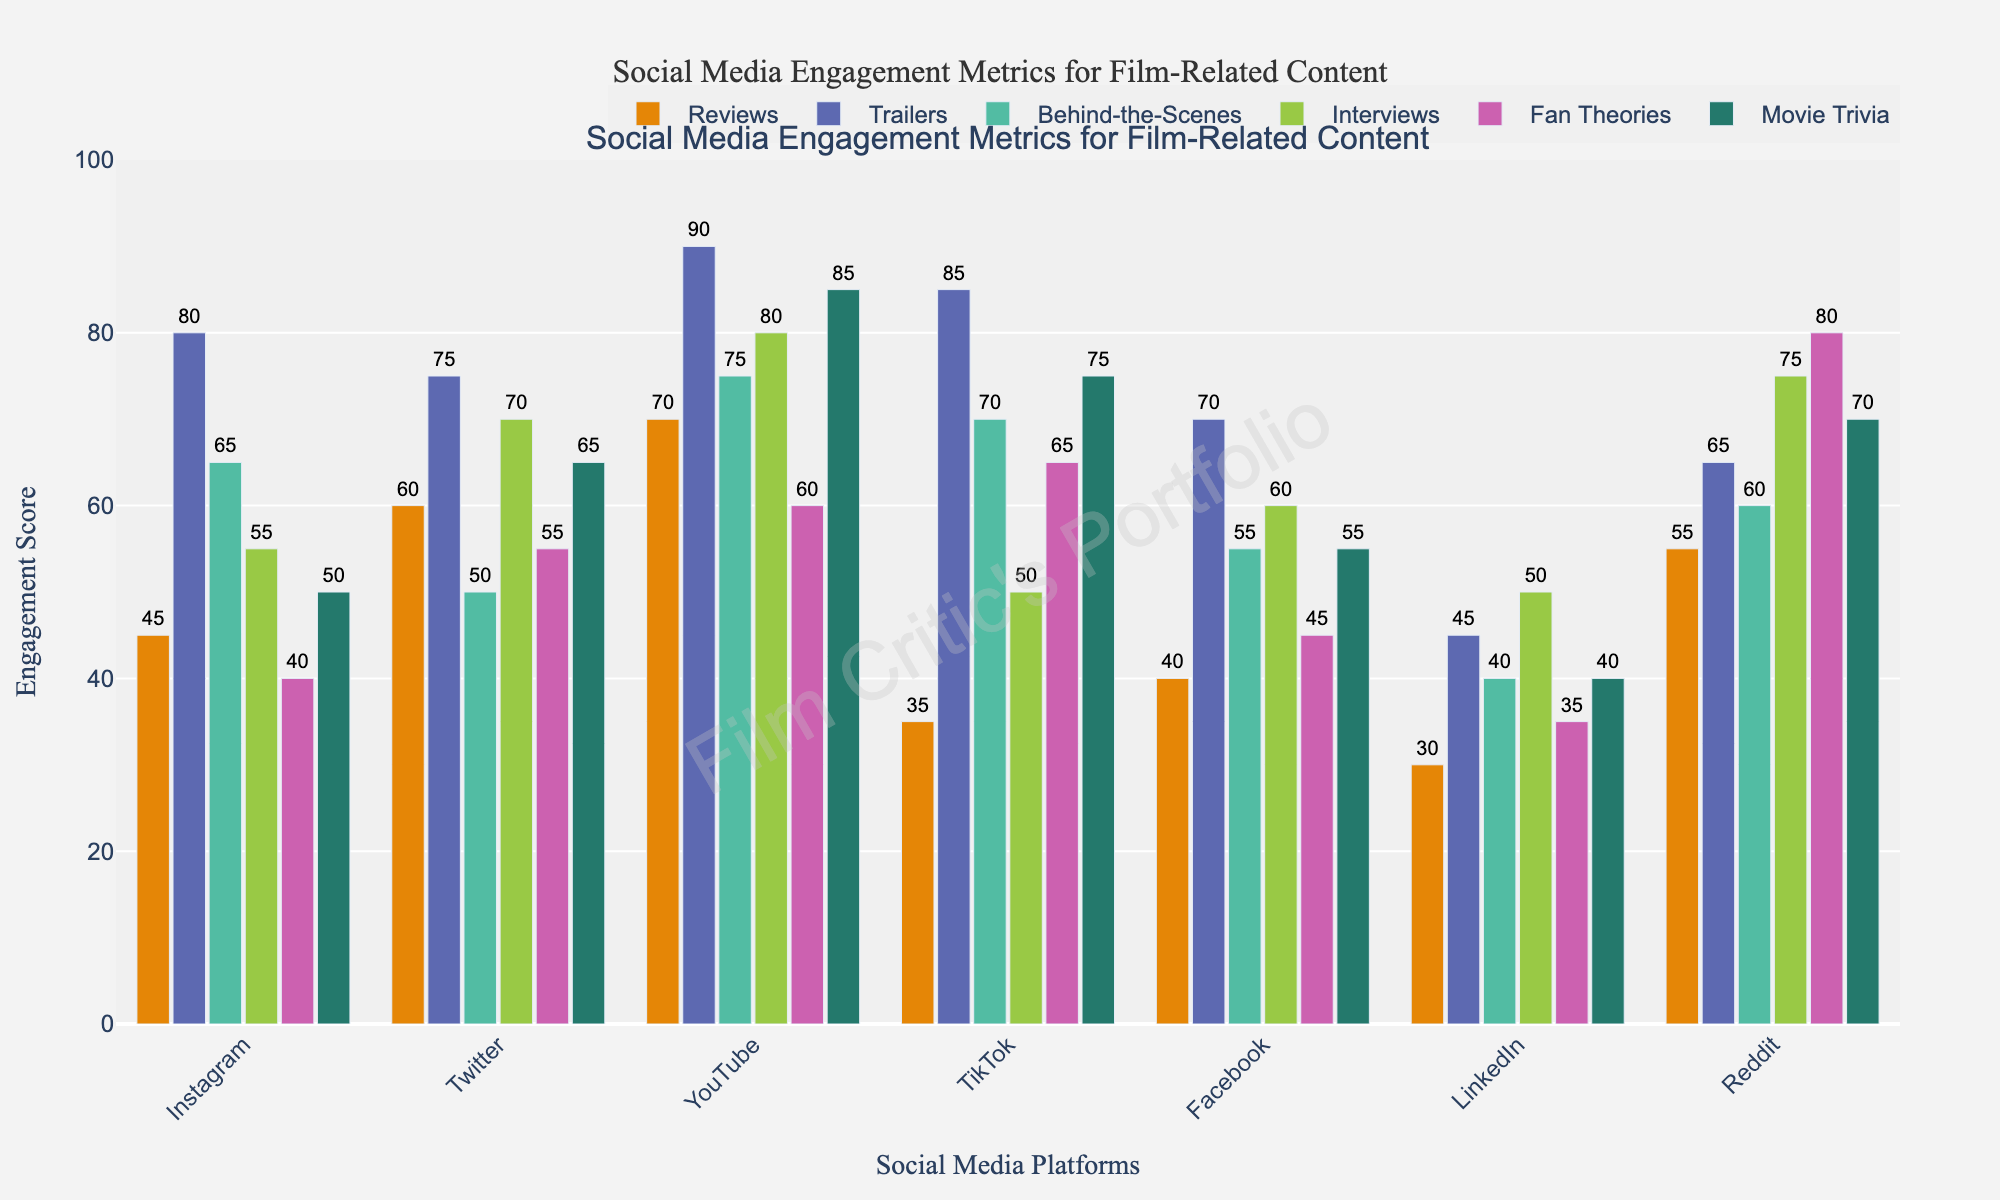What platform has the highest engagement for movie trailers? Observe the tallest bar corresponding to movie trailers across all platforms. The tallest bar for movie trailers is on YouTube, which shows a value of 90.
Answer: YouTube Which content type has the least engagement on LinkedIn? Compare the heights of all the bars for LinkedIn. The shortest bar for LinkedIn is for Behind-the-Scenes content, with a value of 40.
Answer: Behind-the-Scenes What's the difference in engagement for fan theories between Reddit and Instagram? Find the engagement values for fan theories on Reddit and Instagram. For Reddit, the value is 80, and for Instagram, the value is 40. The difference is 80 - 40 = 40.
Answer: 40 On which platform does interviews content have better engagement: Twitter or Facebook? Compare the heights of the bars for interviews content on Twitter and Facebook. For Twitter, the engagement score is 70, while for Facebook, it is 60.
Answer: Twitter What is the average engagement score for fan theories across all platforms? Sum the engagement scores for fan theories across all platforms and divide by the number of platforms. Scores are 40 (Instagram), 55 (Twitter), 60 (YouTube), 65 (TikTok), 45 (Facebook), 35 (LinkedIn), and 80 (Reddit). Sum = 40 + 55 + 60 + 65 + 45 + 35 + 80 = 380. Average = 380 / 7 ≈ 54.29.
Answer: 54.29 Which platform has the most balanced engagement scores across all content types? Inspect the bars for each platform and find the one where the differences between the highest and lowest engagement scores are minimal. LinkedIn shows the least variation with scores close to each other (between 30 and 50).
Answer: LinkedIn How does the total engagement for YouTube compare to the total engagement for TikTok? Sum the engagement scores for YouTube and TikTok across all content types. YouTube: 70 + 90 + 75 + 80 + 60 + 85 = 460. TikTok: 35 + 85 + 70 + 50 + 65 + 75 = 380. The total for YouTube is higher.
Answer: YouTube 